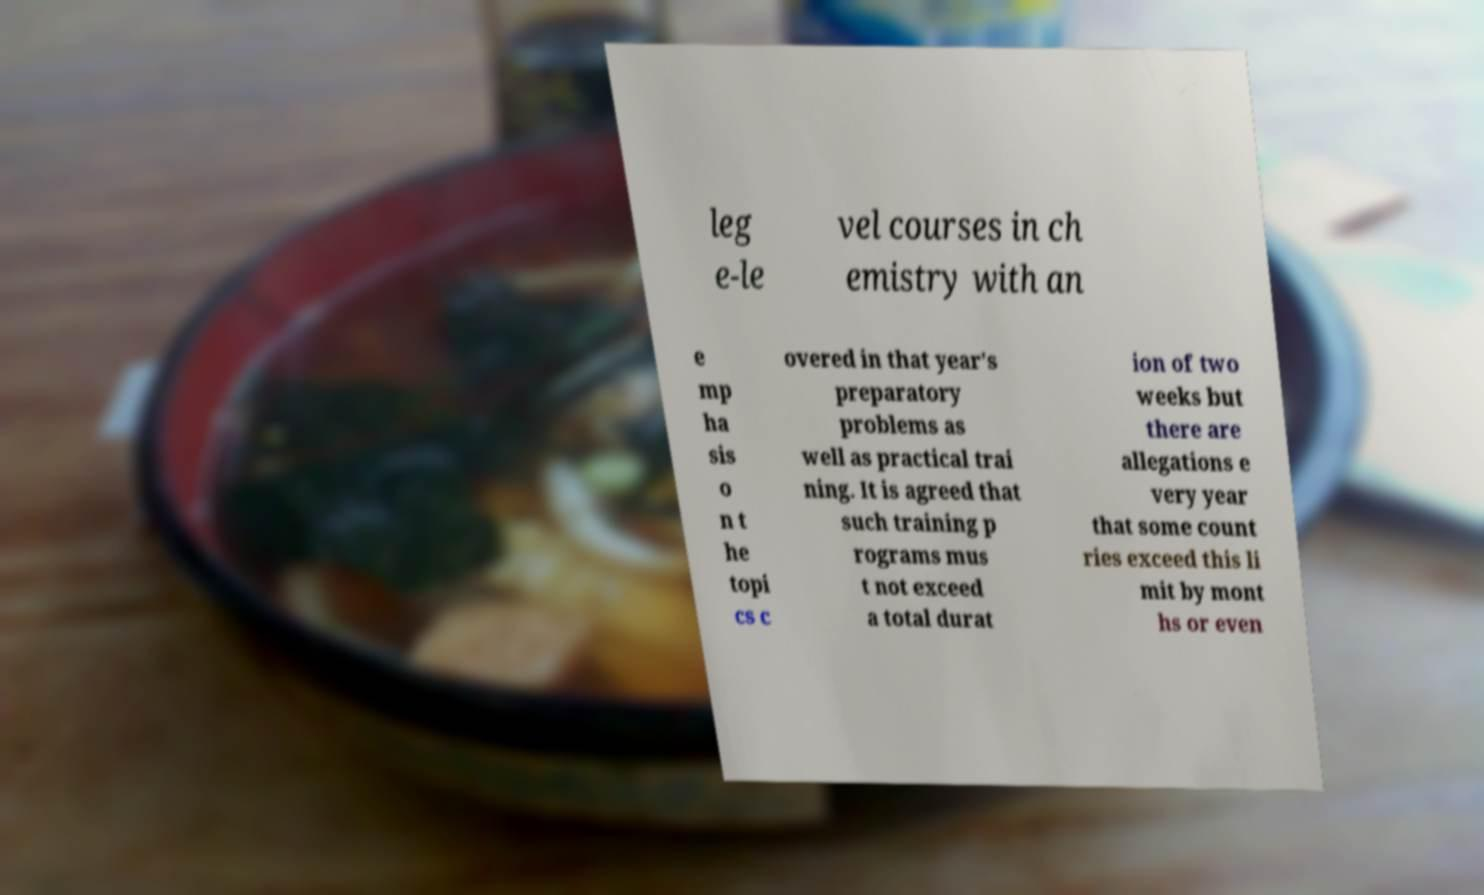Please read and relay the text visible in this image. What does it say? leg e-le vel courses in ch emistry with an e mp ha sis o n t he topi cs c overed in that year's preparatory problems as well as practical trai ning. It is agreed that such training p rograms mus t not exceed a total durat ion of two weeks but there are allegations e very year that some count ries exceed this li mit by mont hs or even 